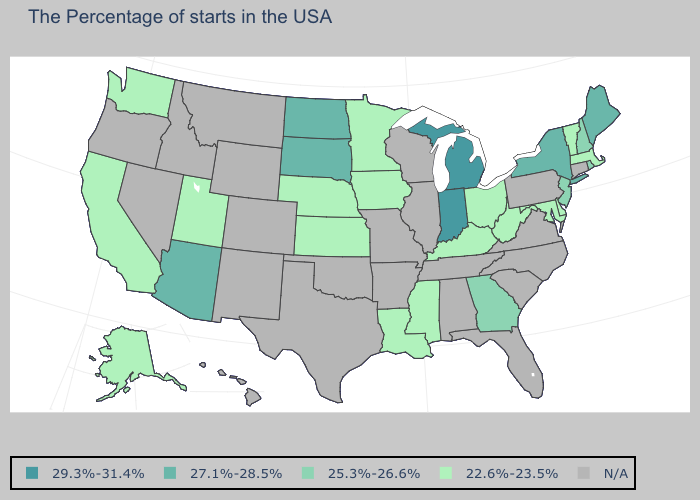Which states have the highest value in the USA?
Quick response, please. Michigan, Indiana. Which states have the lowest value in the USA?
Give a very brief answer. Massachusetts, Vermont, Delaware, Maryland, West Virginia, Ohio, Kentucky, Mississippi, Louisiana, Minnesota, Iowa, Kansas, Nebraska, Utah, California, Washington, Alaska. What is the value of Maryland?
Concise answer only. 22.6%-23.5%. What is the value of Washington?
Keep it brief. 22.6%-23.5%. Does Delaware have the lowest value in the South?
Concise answer only. Yes. What is the highest value in states that border Minnesota?
Give a very brief answer. 27.1%-28.5%. What is the value of Virginia?
Short answer required. N/A. What is the lowest value in the USA?
Short answer required. 22.6%-23.5%. Does Indiana have the highest value in the USA?
Give a very brief answer. Yes. What is the value of Kansas?
Keep it brief. 22.6%-23.5%. Which states have the lowest value in the USA?
Write a very short answer. Massachusetts, Vermont, Delaware, Maryland, West Virginia, Ohio, Kentucky, Mississippi, Louisiana, Minnesota, Iowa, Kansas, Nebraska, Utah, California, Washington, Alaska. Name the states that have a value in the range 25.3%-26.6%?
Keep it brief. Rhode Island, New Hampshire, New Jersey, Georgia. Name the states that have a value in the range 25.3%-26.6%?
Write a very short answer. Rhode Island, New Hampshire, New Jersey, Georgia. 